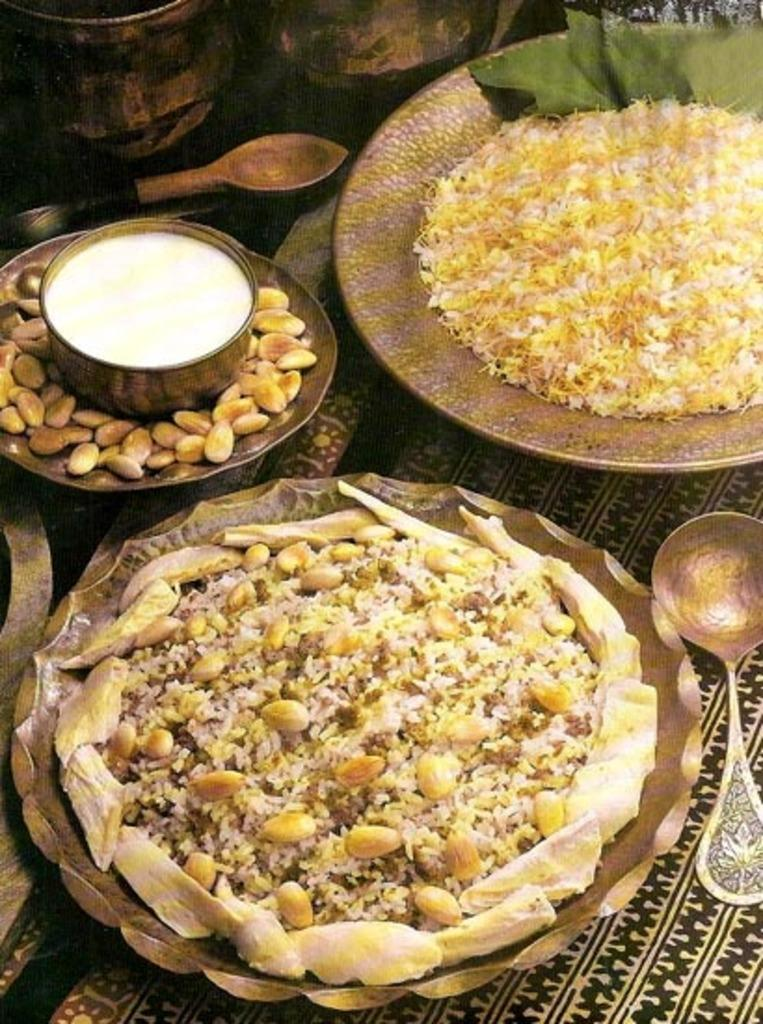What is present on the plate in the image? There are food items in the plate. What else can be seen in the image besides the plate? There is a bowl visible in the image. What type of lawyer is depicted in the image? There is no lawyer present in the image; it only features a plate with food items and a bowl. 